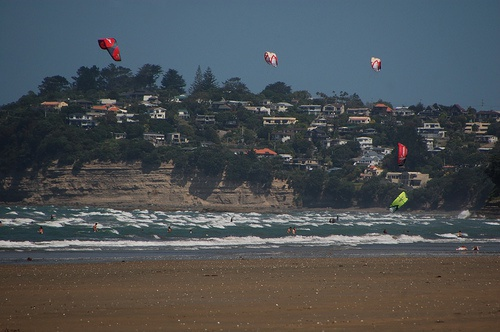Describe the objects in this image and their specific colors. I can see people in blue, gray, purple, and black tones, kite in blue, gray, brown, black, and maroon tones, kite in blue, black, olive, gray, and khaki tones, kite in blue, brown, and maroon tones, and kite in blue, gray, darkgray, brown, and lightgray tones in this image. 